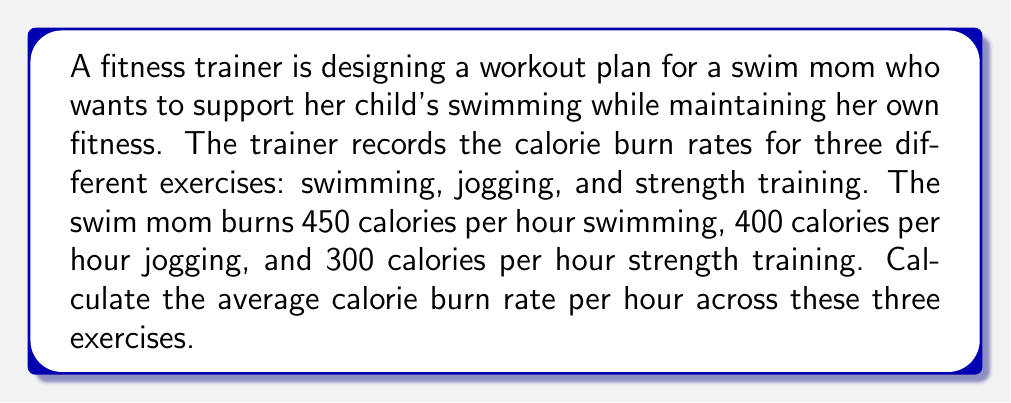Teach me how to tackle this problem. To calculate the average calorie burn rate per hour across the three exercises, we need to:

1. Sum up the calorie burn rates for all exercises:
   $$ \text{Total calories} = 450 + 400 + 300 = 1150 \text{ calories} $$

2. Count the number of exercises:
   $$ \text{Number of exercises} = 3 $$

3. Calculate the average by dividing the total calories by the number of exercises:
   $$ \text{Average} = \frac{\text{Total calories}}{\text{Number of exercises}} $$
   $$ \text{Average} = \frac{1150}{3} = 383.33 \text{ calories per hour} $$

Therefore, the average calorie burn rate across swimming, jogging, and strength training is approximately 383.33 calories per hour.
Answer: 383.33 calories per hour 